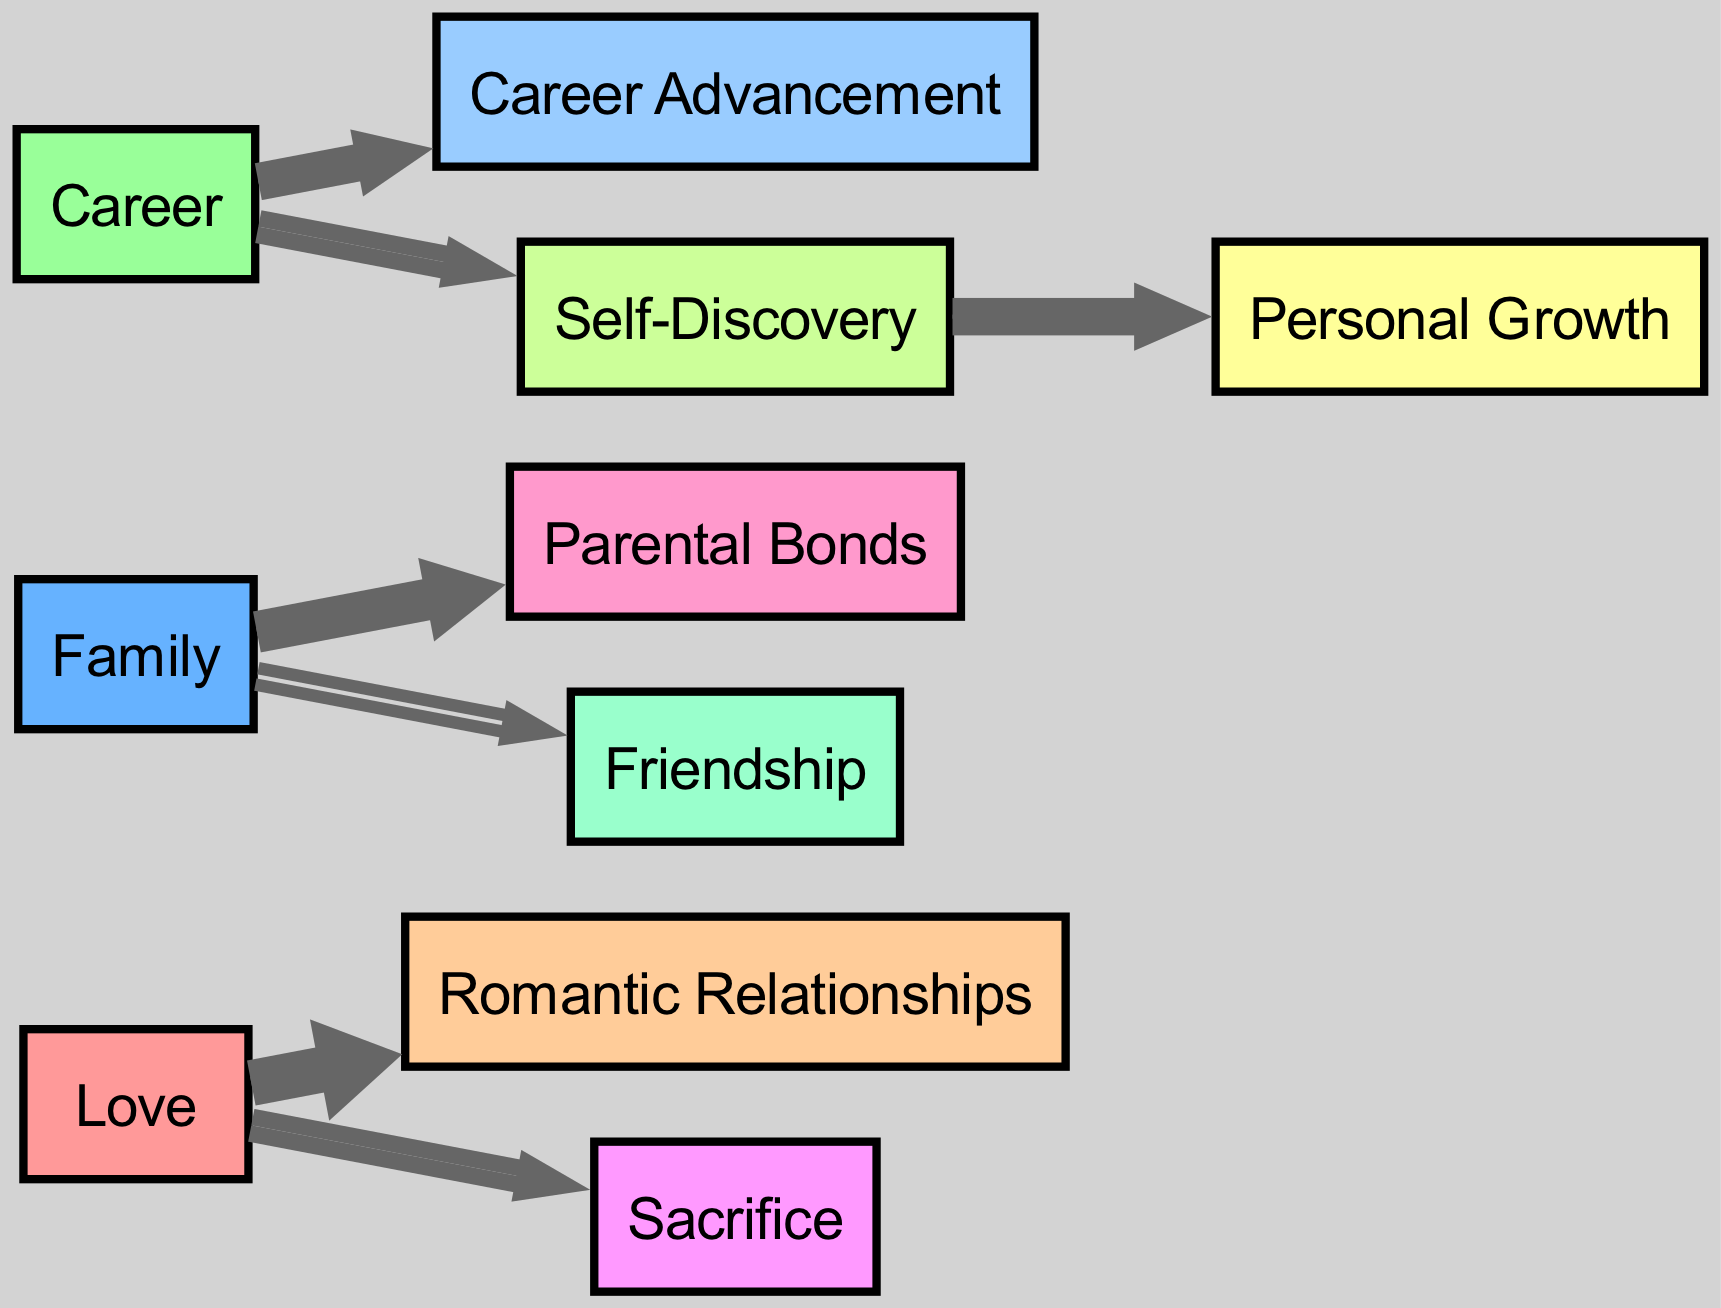What is the total number of nodes in the diagram? The diagram contains a total of 10 nodes, which are Love, Family, Career, Romantic Relationships, Parental Bonds, Career Advancement, Self-Discovery, Sacrifice, Friendship, and Personal Growth. This is counted simply by listing each unique entity involved in the relationships depicted.
Answer: 10 Which theme has the highest flow towards a sub-theme? The theme "Love" has the highest flow towards the sub-theme "Romantic Relationships" with a value of 7. By comparing the values of each link extending from the themes, we identify "Love" as the highest flowing to its sub-theme.
Answer: 7 What is the connection between Career and Self-Discovery? There is a direct connection between "Career" and "Self-Discovery" represented by a link with a value of 4. This indicates a moderate level of flow from the Career theme into Self-Discovery.
Answer: 4 Which theme connects Family to Friendship? The theme "Family" connects to "Friendship" with a flow value of 3. This was determined by identifying the links that extend from the Family node and observing the flow towards Friendship.
Answer: Friendship How many flows originate from the theme "Family"? The theme "Family" has two outgoing flows: one to "Parental Bonds" with a value of 6 and one to "Friendship" with a value of 3, totaling two connections. By totaling the number of unique links stemming from the Family node, we count the two flows.
Answer: 2 What does the term "Personal Growth" connect to in the diagram? "Personal Growth" is connected to "Self-Discovery" with a flow value of 5. Observing the direct link from Self-Discovery, we can determine that it leads into Personal Growth.
Answer: Self-Discovery Which theme is represented by the least amount of flow? The theme "Friendship" has the least amount of flow with a value of 3 coming from "Family." After evaluating the values of all the connections, Friendship has the lowest value indicated in the diagram.
Answer: 3 Which theme involves both love and sacrifice? The theme "Sacrifice" is associated with "Love" since there is a flow of 4 from Love to Sacrifice. This connection is established by checking the flows leading out from Love, demonstrating the relationship.
Answer: Sacrifice What is the total flow value from Love? The total flow value from "Love" is calculated by adding the values of its connections: 7 (to Romantic Relationships) + 4 (to Sacrifice), which equals 11. By summing these figures, we see the overall impact of Love represented in the flows.
Answer: 11 